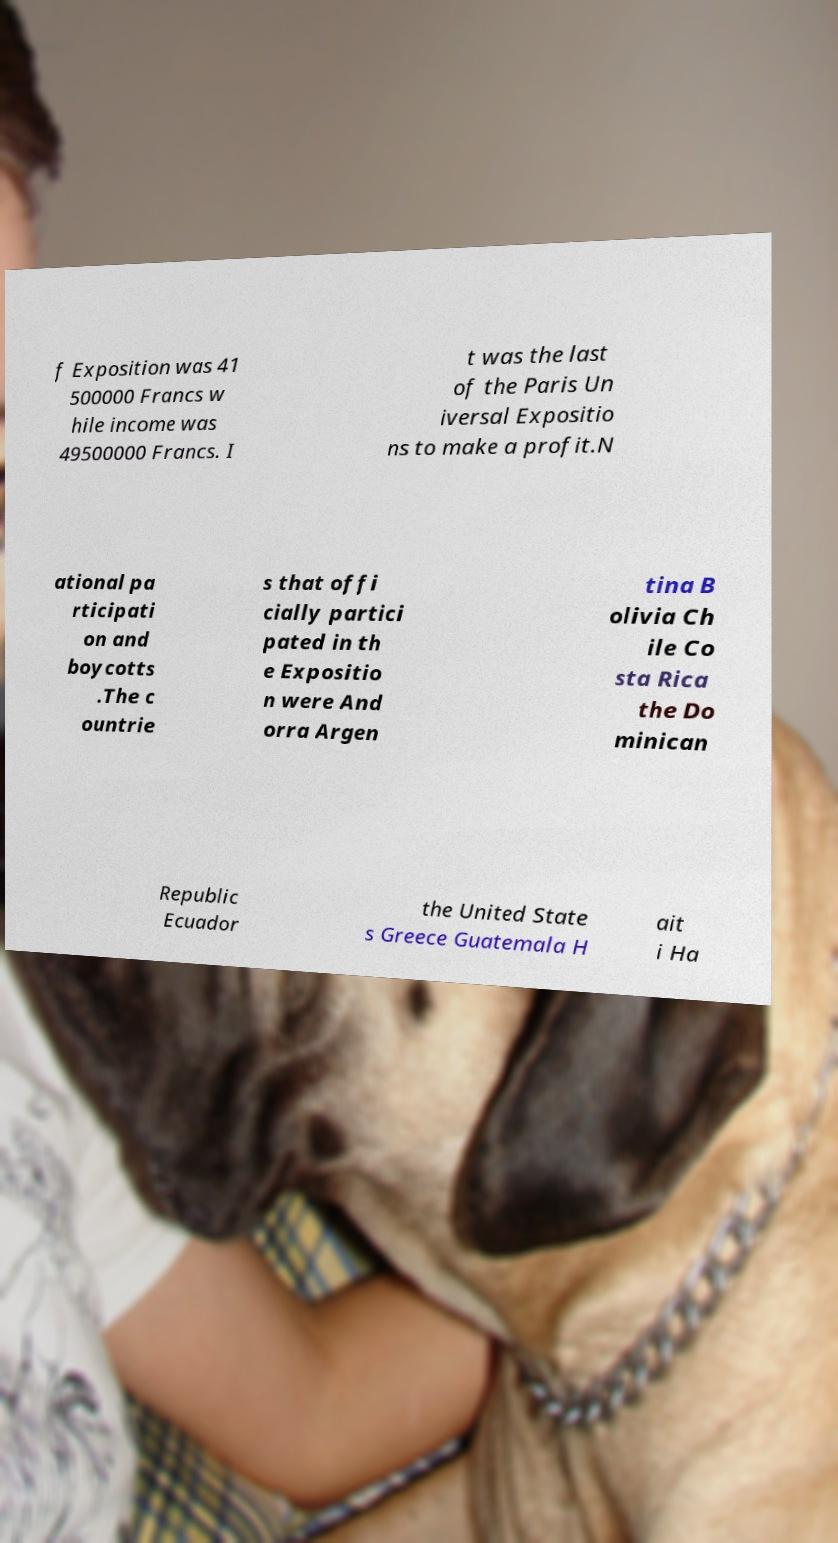What messages or text are displayed in this image? I need them in a readable, typed format. f Exposition was 41 500000 Francs w hile income was 49500000 Francs. I t was the last of the Paris Un iversal Expositio ns to make a profit.N ational pa rticipati on and boycotts .The c ountrie s that offi cially partici pated in th e Expositio n were And orra Argen tina B olivia Ch ile Co sta Rica the Do minican Republic Ecuador the United State s Greece Guatemala H ait i Ha 